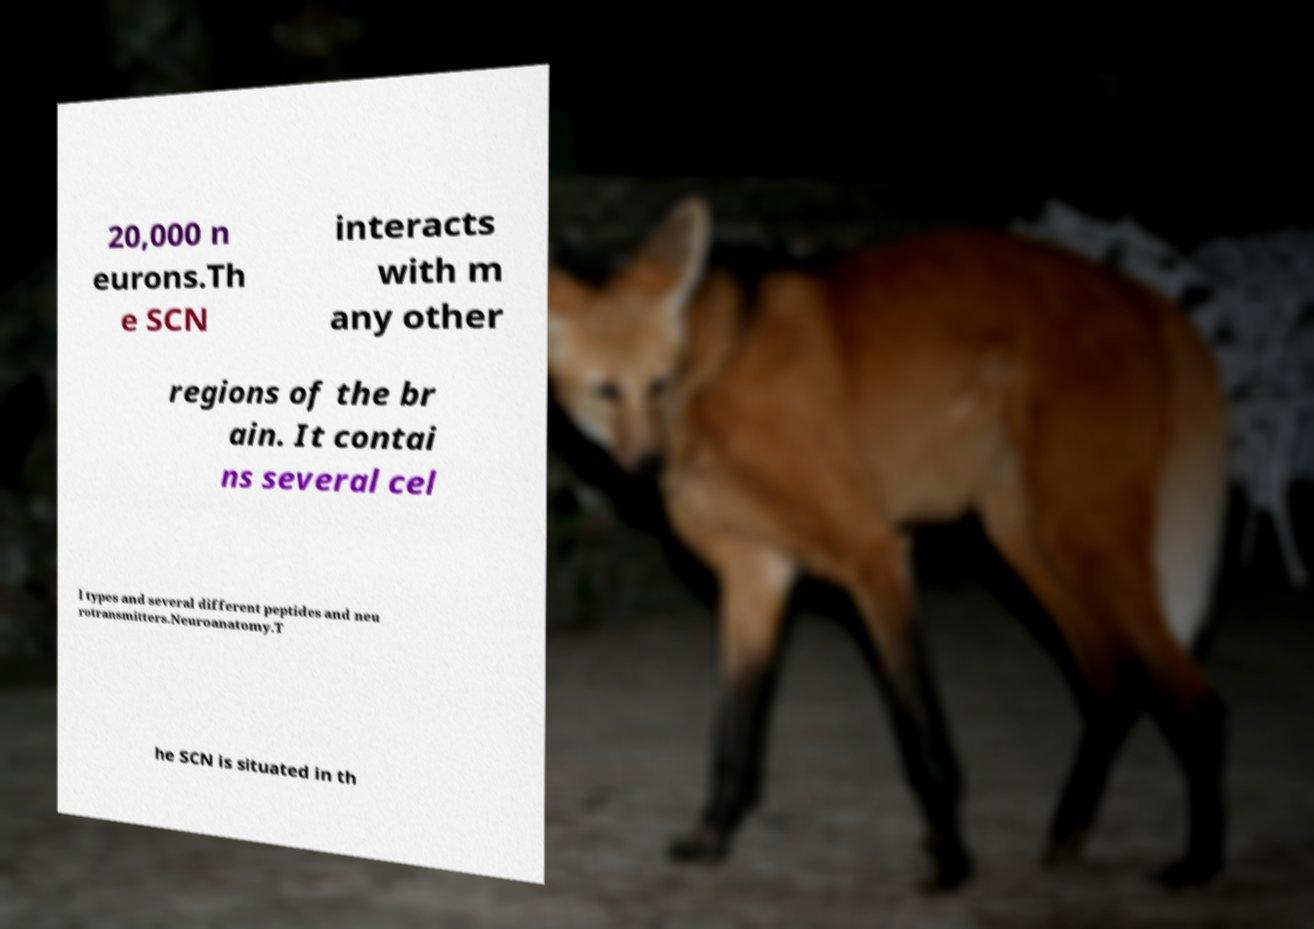For documentation purposes, I need the text within this image transcribed. Could you provide that? 20,000 n eurons.Th e SCN interacts with m any other regions of the br ain. It contai ns several cel l types and several different peptides and neu rotransmitters.Neuroanatomy.T he SCN is situated in th 